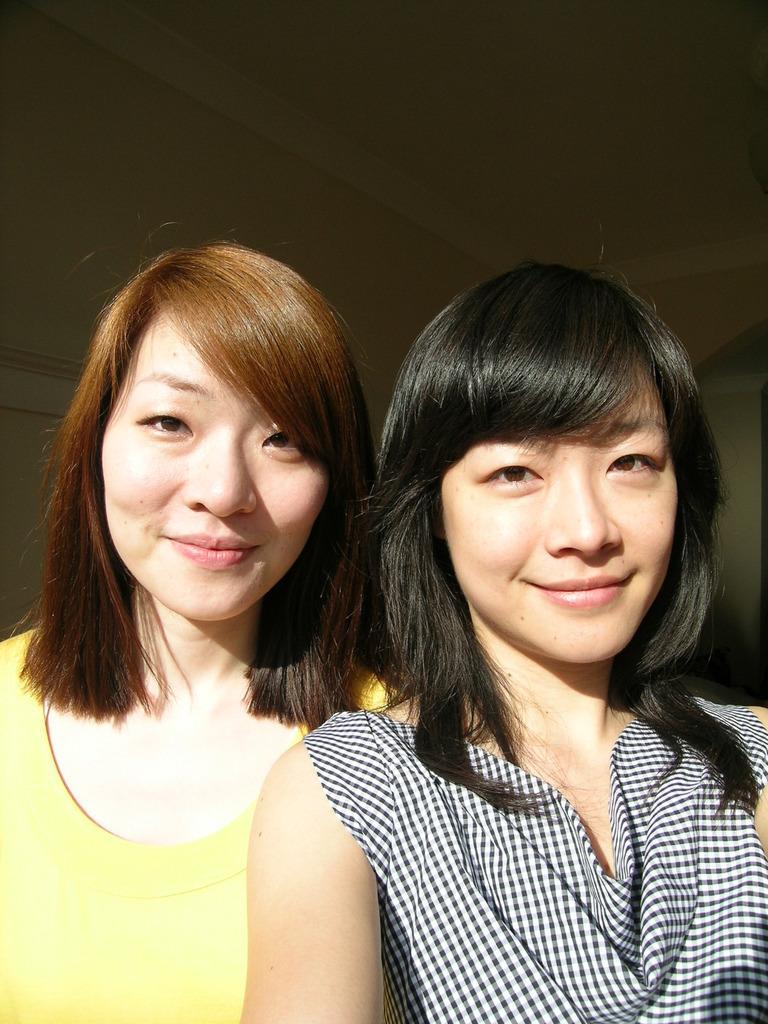Please provide a concise description of this image. In this image I can see two people with yellow, white and black color dress. In the background I can see the wall. 